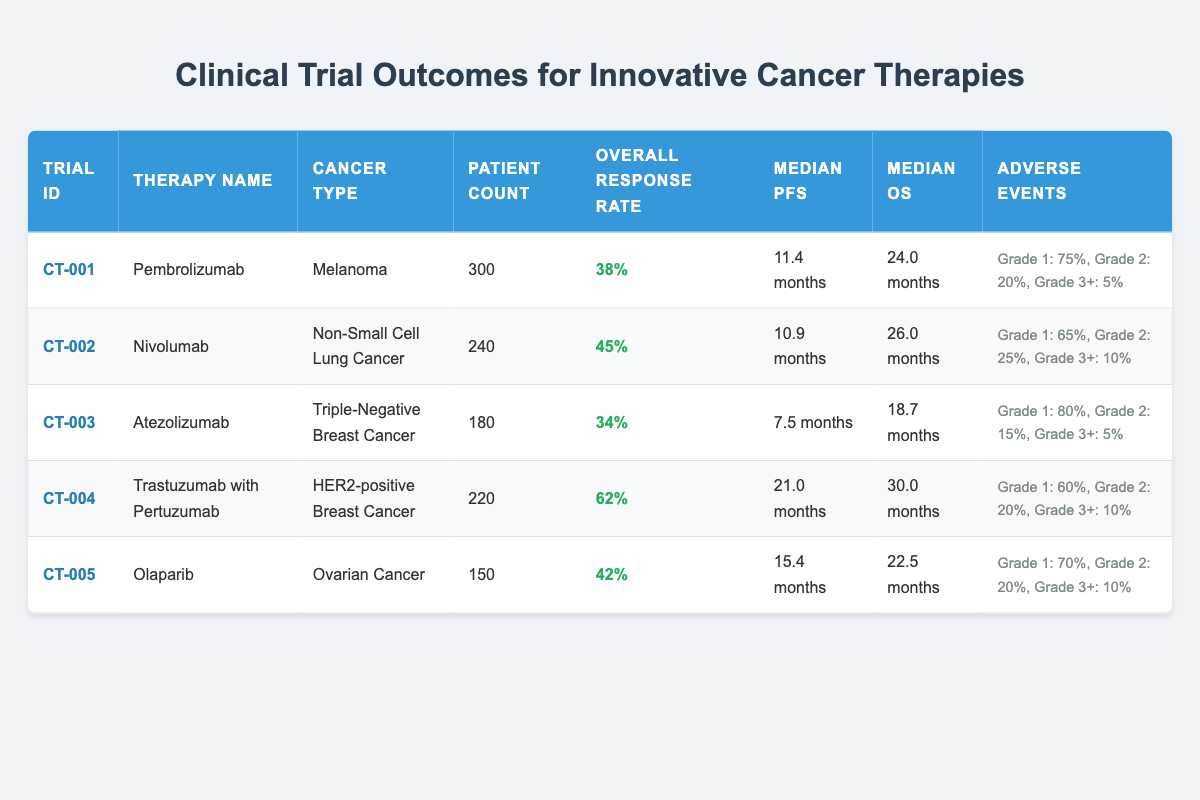What is the overall response rate for Atezolizumab? The overall response rate for Atezolizumab, which treats Triple-Negative Breast Cancer, is listed directly in the table as 34%.
Answer: 34% How many patients were treated with Nivolumab? The table shows the patient count for Nivolumab, which is listed as 240.
Answer: 240 Which therapy has the highest median overall survival? By examining the median overall survival values in the table, Trastuzumab with Pertuzumab has the highest at 30.0 months.
Answer: 30.0 months What is the average overall response rate of all therapies listed? First, we add up the response rates: 38% + 45% + 34% + 62% + 42% = 221%. Then, we divide by the number of therapies (5): 221% / 5 = 44.2%.
Answer: 44.2% Do more than 50% of patients experience grade 1 adverse events with Pembrolizumab? The table shows that 75% of patients experience grade 1 adverse events with Pembrolizumab, which is greater than 50%.
Answer: Yes Which cancer type had the lowest median progression-free survival? The median progression-free survival values are: 11.4 months (Pembrolizumab), 10.9 months (Nivolumab), 7.5 months (Atezolizumab), 21.0 months (Trastuzumab with Pertuzumab), and 15.4 months (Olaparib). Atezolizumab has the lowest at 7.5 months.
Answer: 7.5 months Is the number of patients in CT-005 greater than the number in CT-003? The table shows that CT-005 (Olaparib) has 150 patients, while CT-003 (Atezolizumab) has 180 patients. Therefore, CT-005 has fewer patients than CT-003.
Answer: No What percentage of patients experienced grade 3 adverse events when treated with Nivolumab? The table indicates that 10 patients experienced grade 3 and above adverse events with Nivolumab out of 240 patients. Hence, the percentage is (10/240)*100 ≈ 4.2%.
Answer: 4.2% 